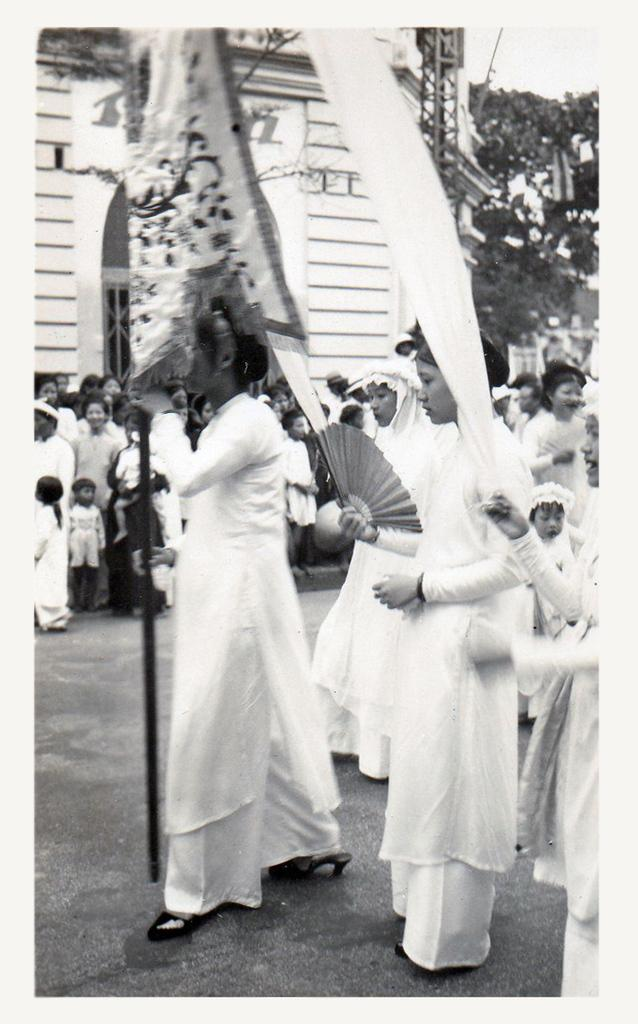What are the people in the image doing? The people in the image are walking on the road. What can be seen in the background of the image? There are buildings and trees in the background. What type of arch can be seen in the alley in the image? There is no arch or alley present in the image; it features people walking on the road with buildings and trees in the background. 